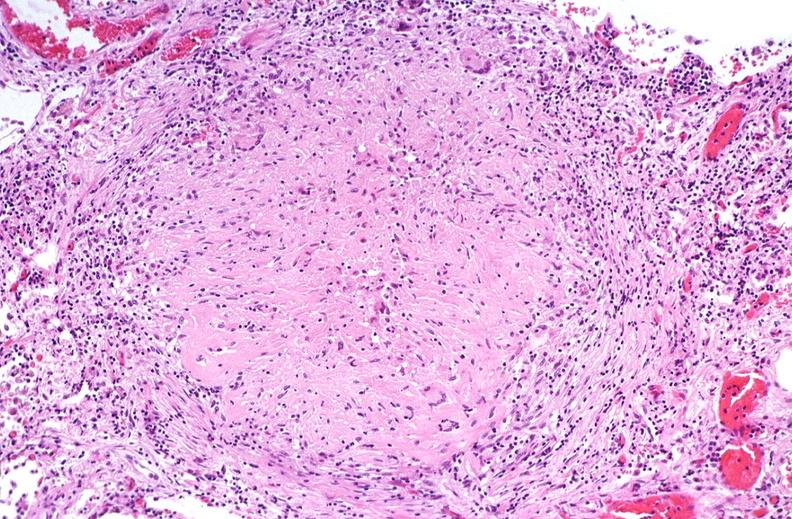where is this?
Answer the question using a single word or phrase. Lung 